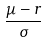Convert formula to latex. <formula><loc_0><loc_0><loc_500><loc_500>\frac { \mu - r } { \sigma }</formula> 